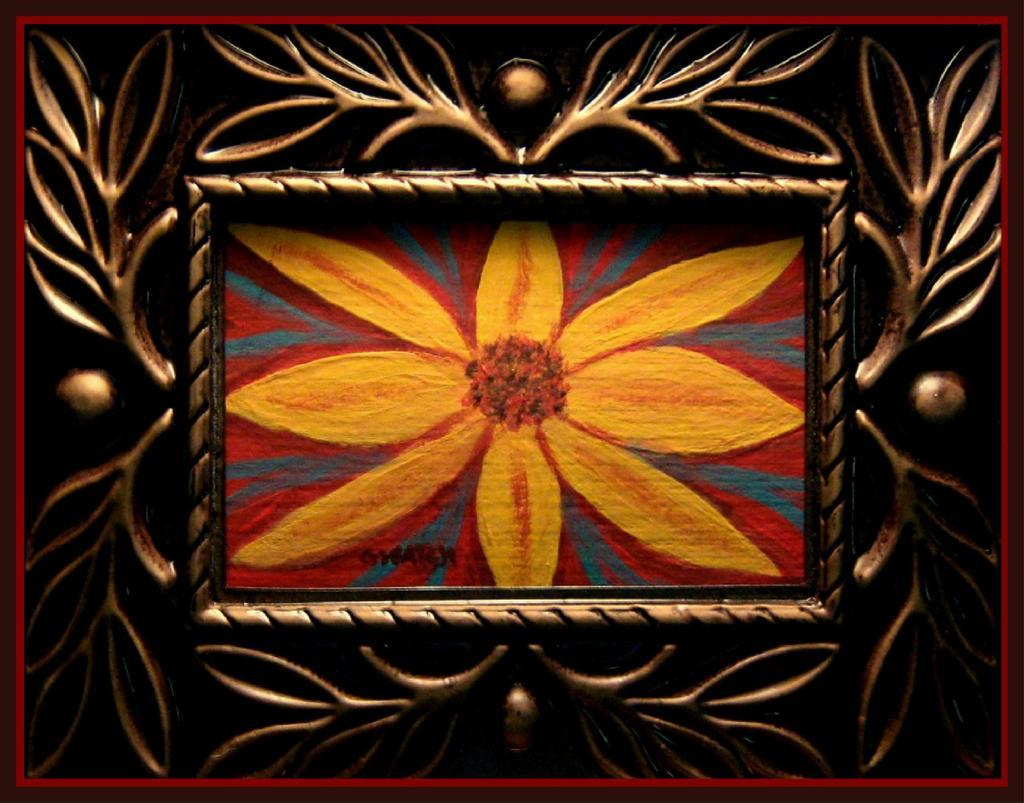What object can be seen in the image? There is a photo frame in the image. What type of bird is flying over the nation in the image? There is no bird or nation present in the image; it only features a photo frame. 